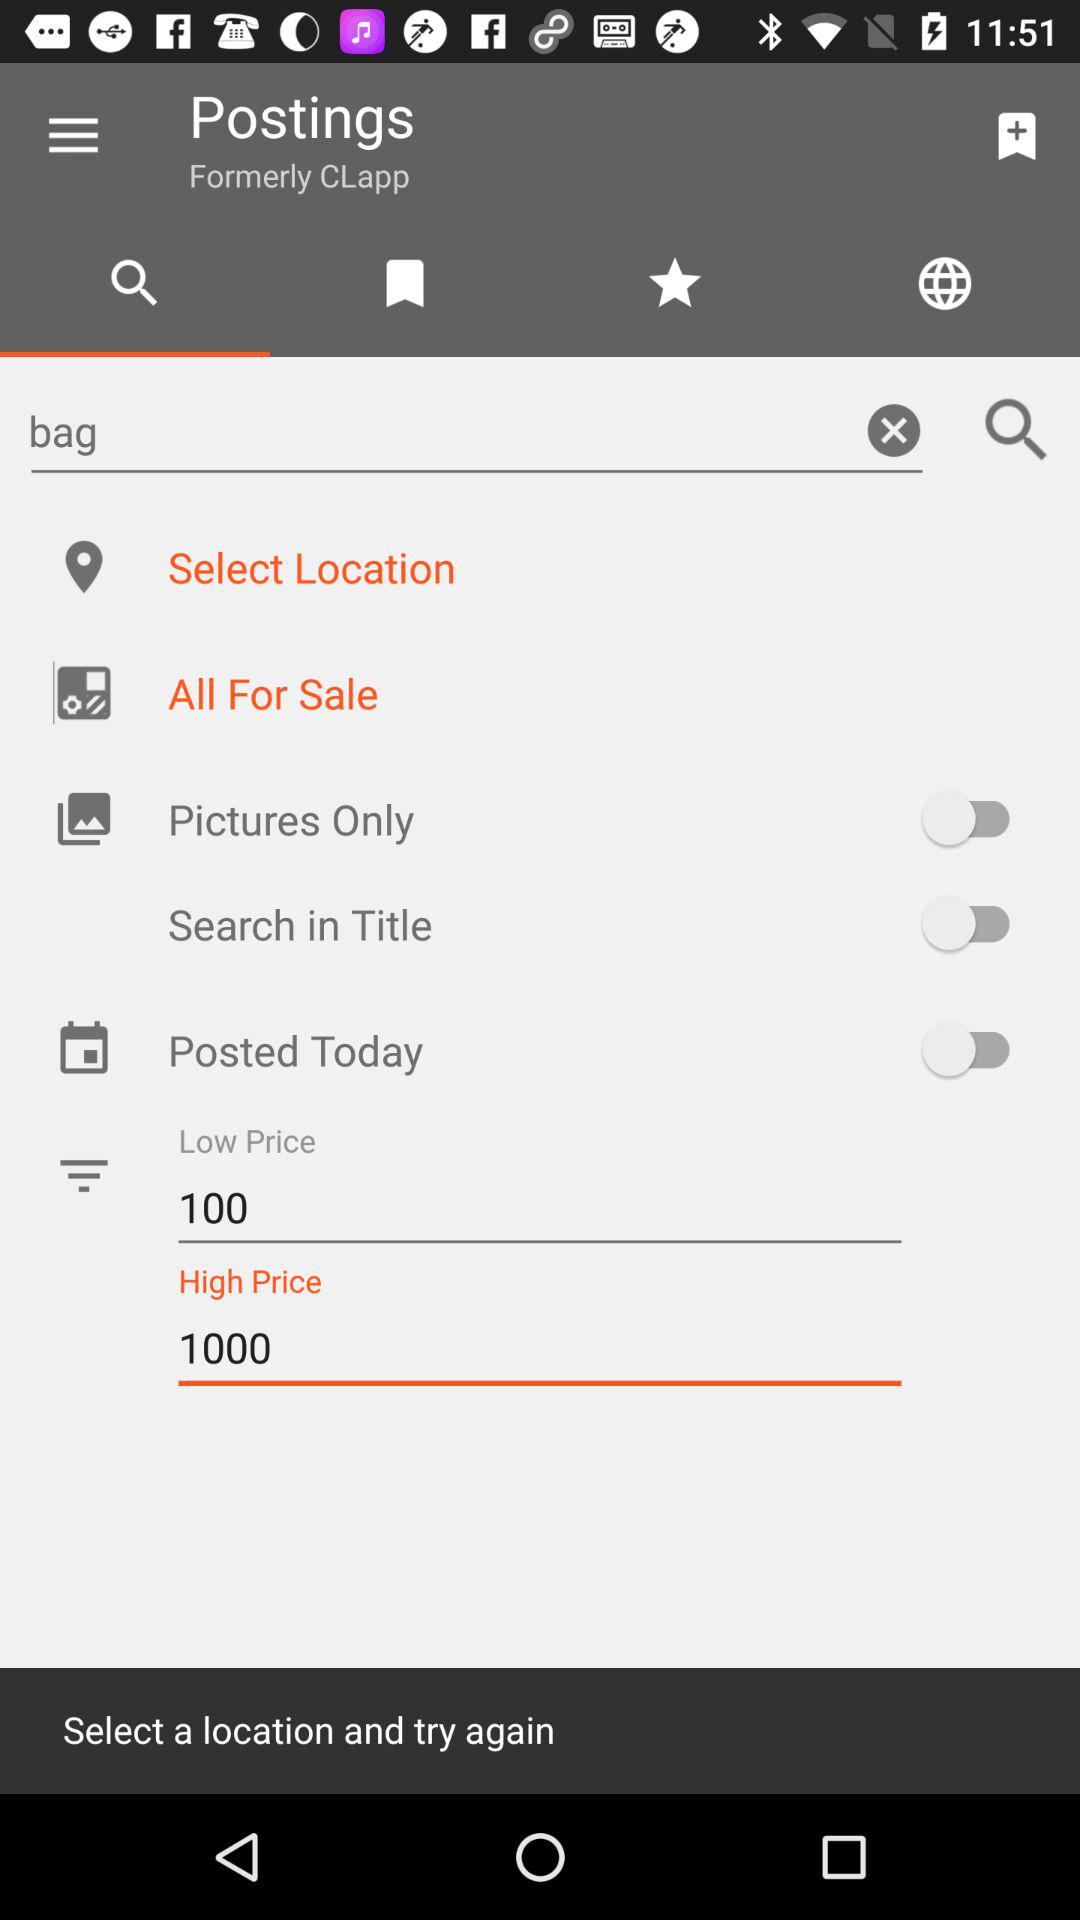What is the status of "Posted Today"? The status is "off". 